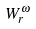Convert formula to latex. <formula><loc_0><loc_0><loc_500><loc_500>W _ { r } ^ { \omega }</formula> 